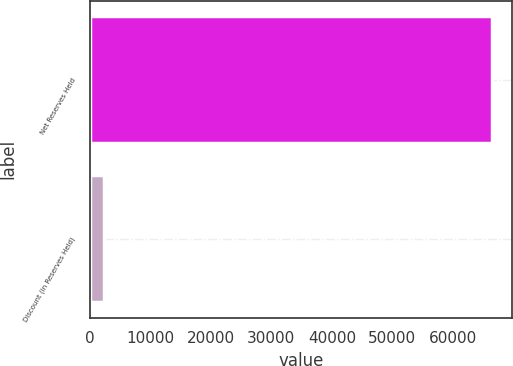Convert chart to OTSL. <chart><loc_0><loc_0><loc_500><loc_500><bar_chart><fcel>Net Reserves Held<fcel>Discount (in Reserves Held)<nl><fcel>66496.1<fcel>2264<nl></chart> 